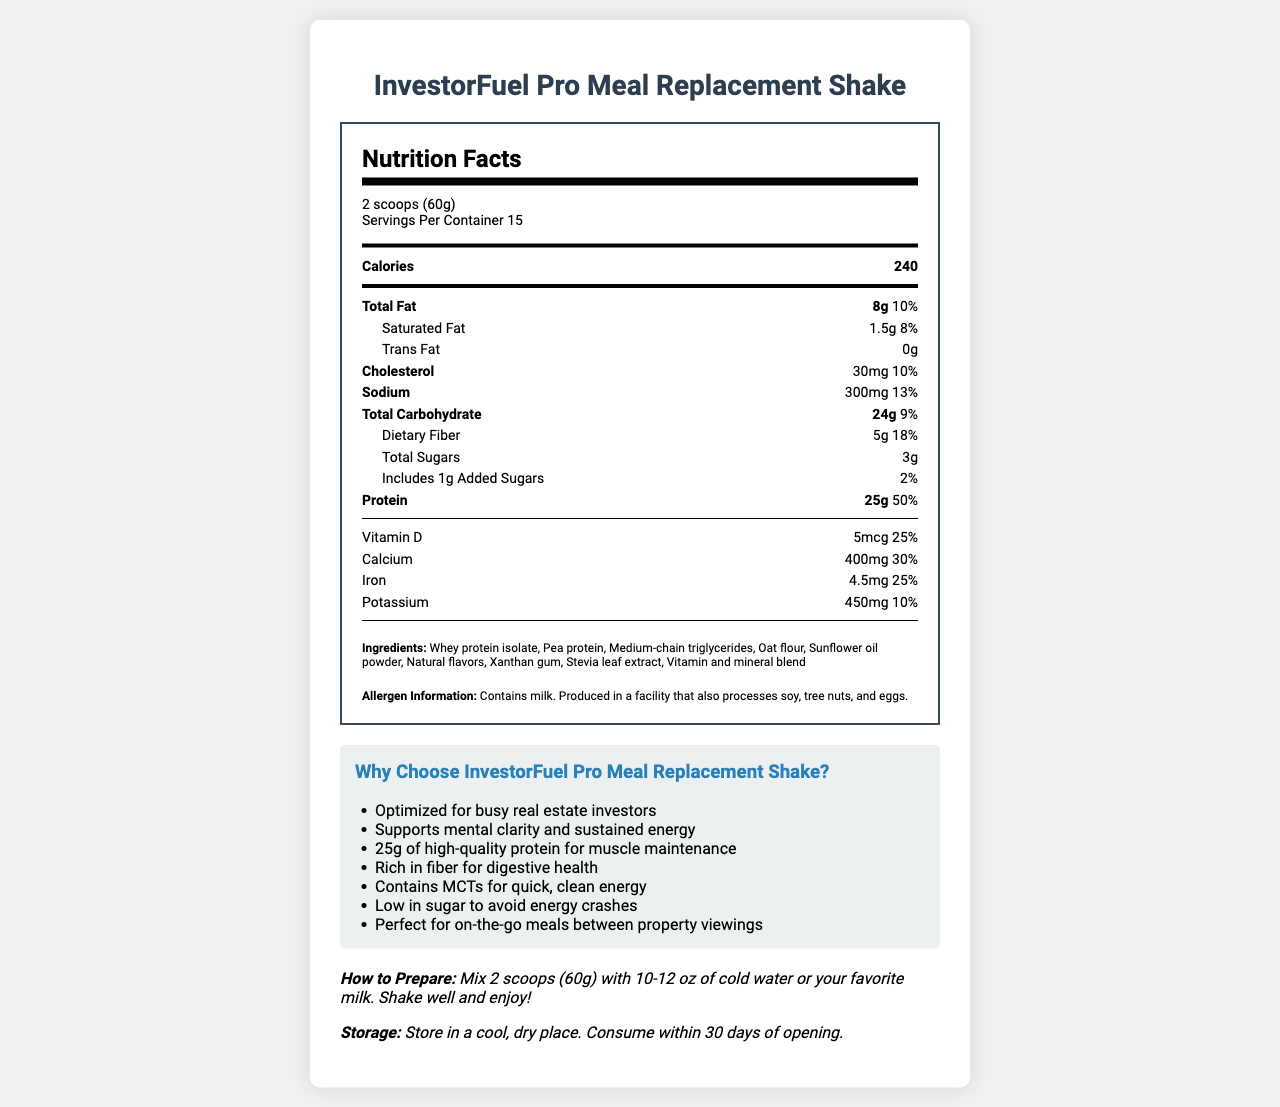what is the total fat content per serving? The document lists the total fat content as 8g per serving.
Answer: 8g how much protein is in one serving of InvestorFuel Pro Meal Replacement Shake? The document indicates that each serving contains 25g of protein.
Answer: 25g what is the serving size for the InvestorFuel Pro Meal Replacement Shake? The serving size is specified as 2 scoops (60g).
Answer: 2 scoops (60g) how many servings are there per container? The nutrition facts state that there are 15 servings per container.
Answer: 15 how many calories are in one serving? The calorie content per serving is listed as 240 calories.
Answer: 240 what is the amount of dietary fiber in one serving? The document states that each serving contains 5g of dietary fiber.
Answer: 5g which vitamin is present in the highest percentage of the daily value? 
A. Vitamin A 
B. Vitamin C 
C. Vitamin D 
D. Vitamin B12  
E. Magnesium Vitamin B12 is present at 100% of the daily value, which is the highest among the listed vitamins and minerals.
Answer: D. Vitamin B12 InvestorFuel Pro Meal Replacement Shake contains which of the following allergens? 
I. Milk 
II. Soy 
III. Tree Nuts 
IV. Eggs The allergen information states that the product contains milk.
Answer: I. Milk does this product contain any trans fat? The document specifies that the product contains 0g of trans fat.
Answer: No what are the main benefits of the InvestorFuel Pro Meal Replacement Shake? The marketing claims section lists several benefits including optimization for busy real estate investors, support for mental clarity and sustained energy, high protein content, high fiber, MCTs for clean energy, low sugar content, and convenience for on-the-go meals.
Answer: Optimized for busy real estate investors, supports mental clarity and sustained energy, high protein for muscle maintenance, rich in fiber, contains MCTs for clean energy, low in sugar, perfect for on-the-go meals what ingredients are used in this product? The ingredients section lists all the ingredients used in the product.
Answer: Whey protein isolate, Pea protein, Medium-chain triglycerides, Oat flour, Sunflower oil powder, Natural flavors, Xanthan gum, Stevia leaf extract, Vitamin and mineral blend how should the InvestorFuel Pro Meal Replacement Shake be stored? The storage instructions state to store the product in a cool, dry place and to consume it within 30 days of opening.
Answer: Store in a cool, dry place. Consume within 30 days of opening what is the recommended preparation method for this shake? The preparation instructions recommend mixing 2 scoops (60g) with 10-12 oz of cold water or milk, and shaking well before consuming.
Answer: Mix 2 scoops (60g) with 10-12 oz of cold water or your favorite milk. Shake well and enjoy! how much iron is in one serving? The document states that one serving contains 4.5mg of iron.
Answer: 4.5mg is the shake suitable for someone with a soy allergy? The document mentions that the product is produced in a facility that processes soy, but it does not specify if the product itself contains soy.
Answer: Cannot be determined summarize the main nutritional and marketing highlights of the InvestorFuel Pro Meal Replacement Shake. This summary covers the key nutritional facts, target market, benefits, allergens, and convenience features as described in the document.
Answer: The InvestorFuel Pro Meal Replacement Shake provides 240 calories per 2-scoop serving, with notable nutritional contents including 25g of protein, 8g of total fat, 24g of carbohydrates, 5g of dietary fiber, and multiple essential vitamins and minerals. It is optimized for real estate investors, aiming to support mental clarity and sustained energy, while being low in sugar and quick to prepare, perfect for busy schedules. The product also contains allergens such as milk and is processed in a facility that handles soy, tree nuts, and eggs. 